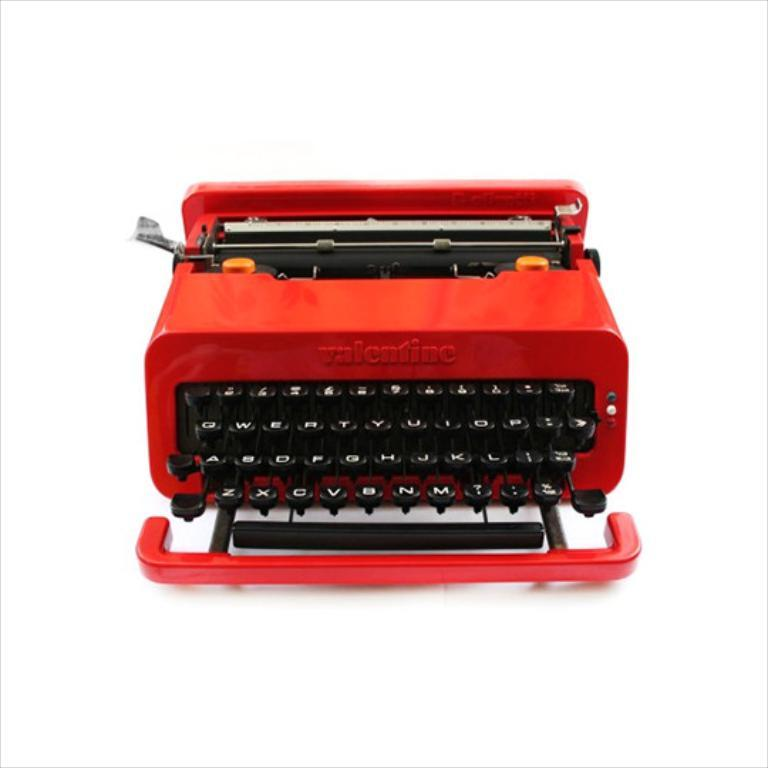<image>
Give a short and clear explanation of the subsequent image. a typewriter with valentine written on the top 